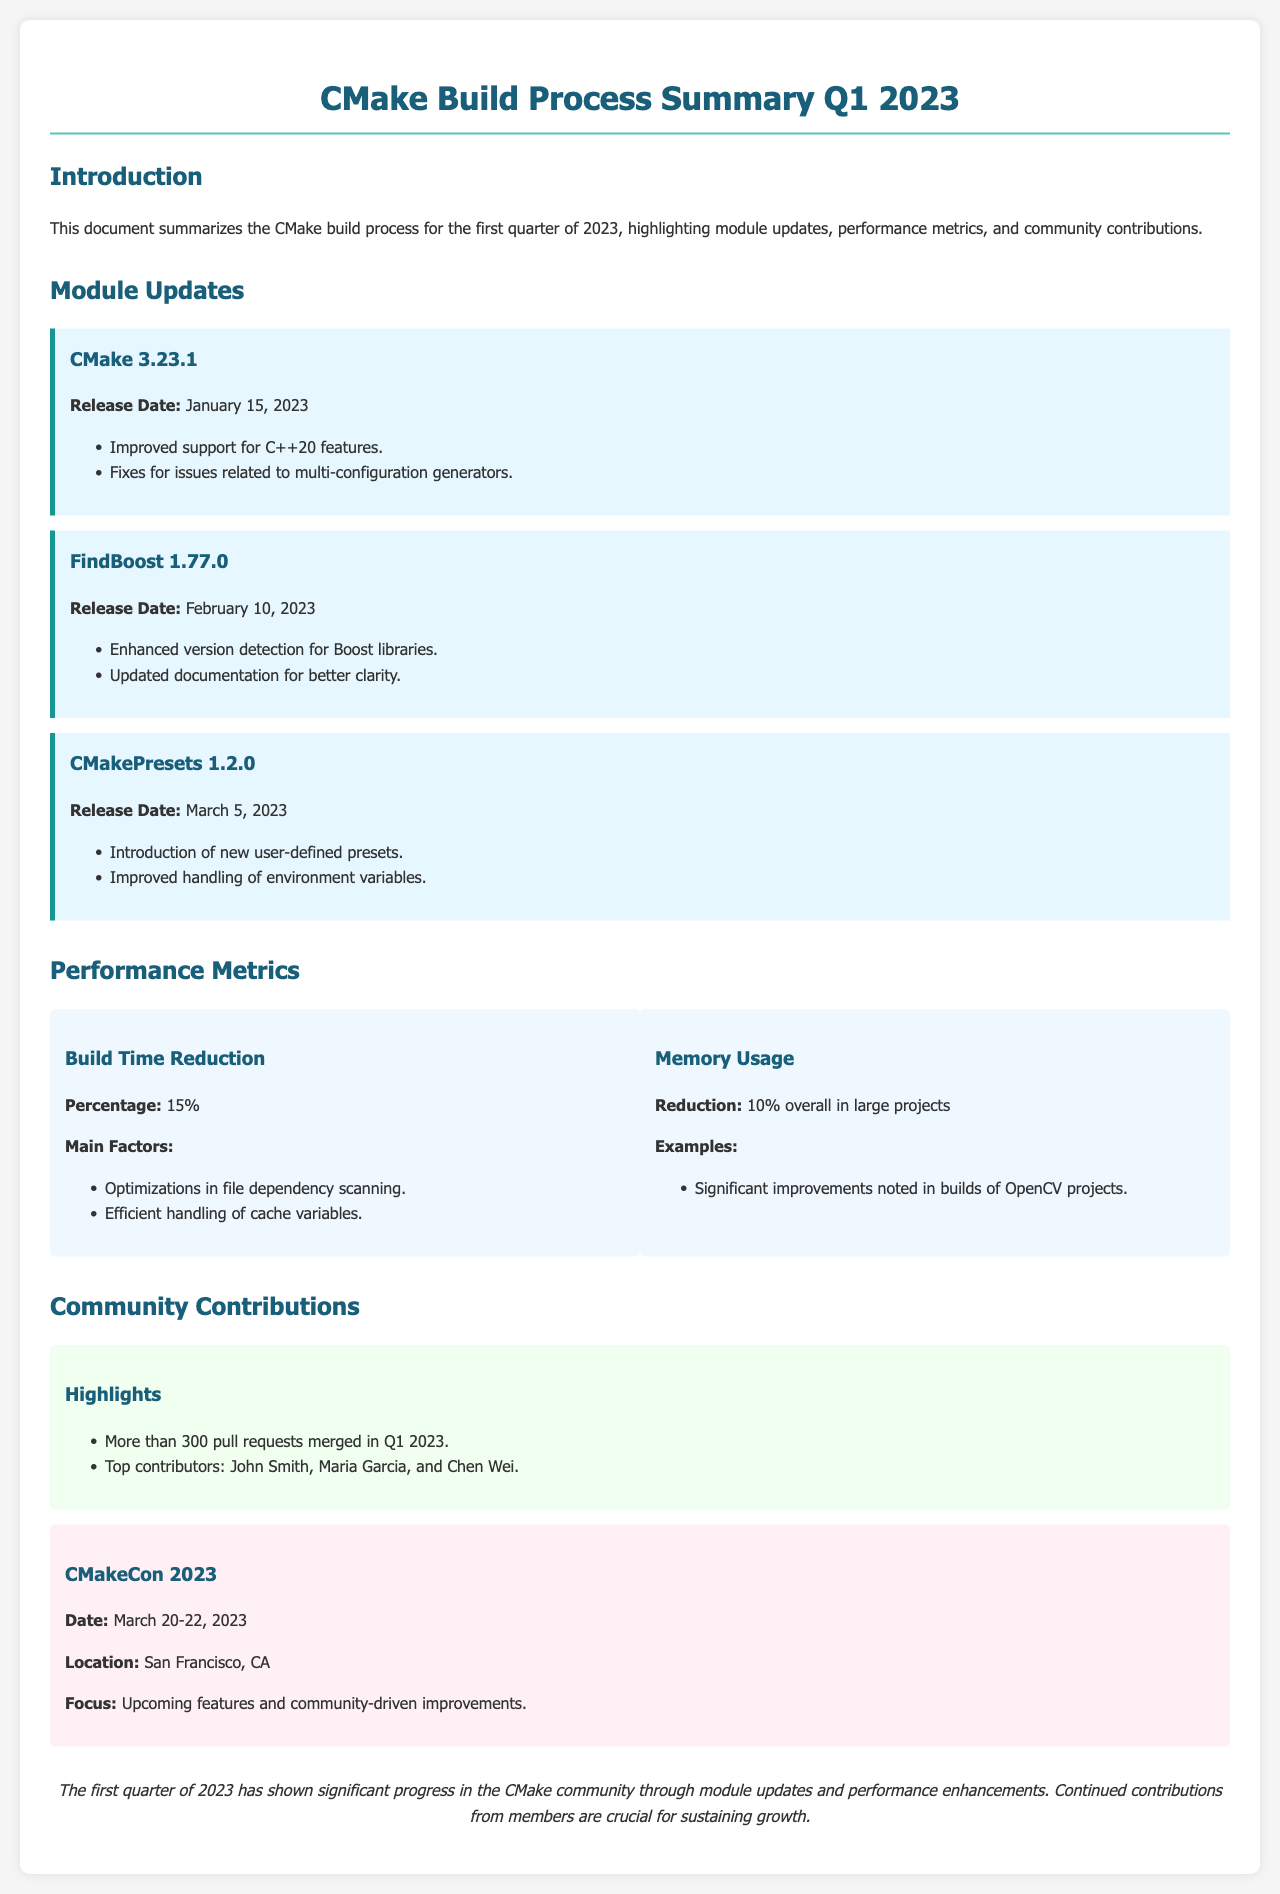What is the release date of CMake 3.23.1? The release date is specified in the document under the CMake 3.23.1 module update section.
Answer: January 15, 2023 What percentage reduction in build time was reported? The percentage reduction is mentioned in the Performance Metrics section under Build Time Reduction.
Answer: 15% Who are the top contributors highlighted in the community contributions? The names of the top contributors are listed in the Community Contributions section.
Answer: John Smith, Maria Garcia, Chen Wei What new feature was introduced in CMakePresets 1.2.0? The introduction of new user-defined presets is specified in the CMakePresets module update section.
Answer: New user-defined presets What is the overall memory usage reduction reported in large projects? The reduction figure is stated in the Performance Metrics section under Memory Usage.
Answer: 10% What event took place on March 20-22, 2023? The specific event is documented in the Community Contributions section with its details.
Answer: CMakeCon 2023 What improvements were noted in builds of which project? The specific project is mentioned in the Performance Metrics section under Memory Usage, indicating where improvements were seen.
Answer: OpenCV projects What was the main focus of CMakeCon 2023? The focus of the event is outlined in the Community Contributions section.
Answer: Upcoming features and community-driven improvements 